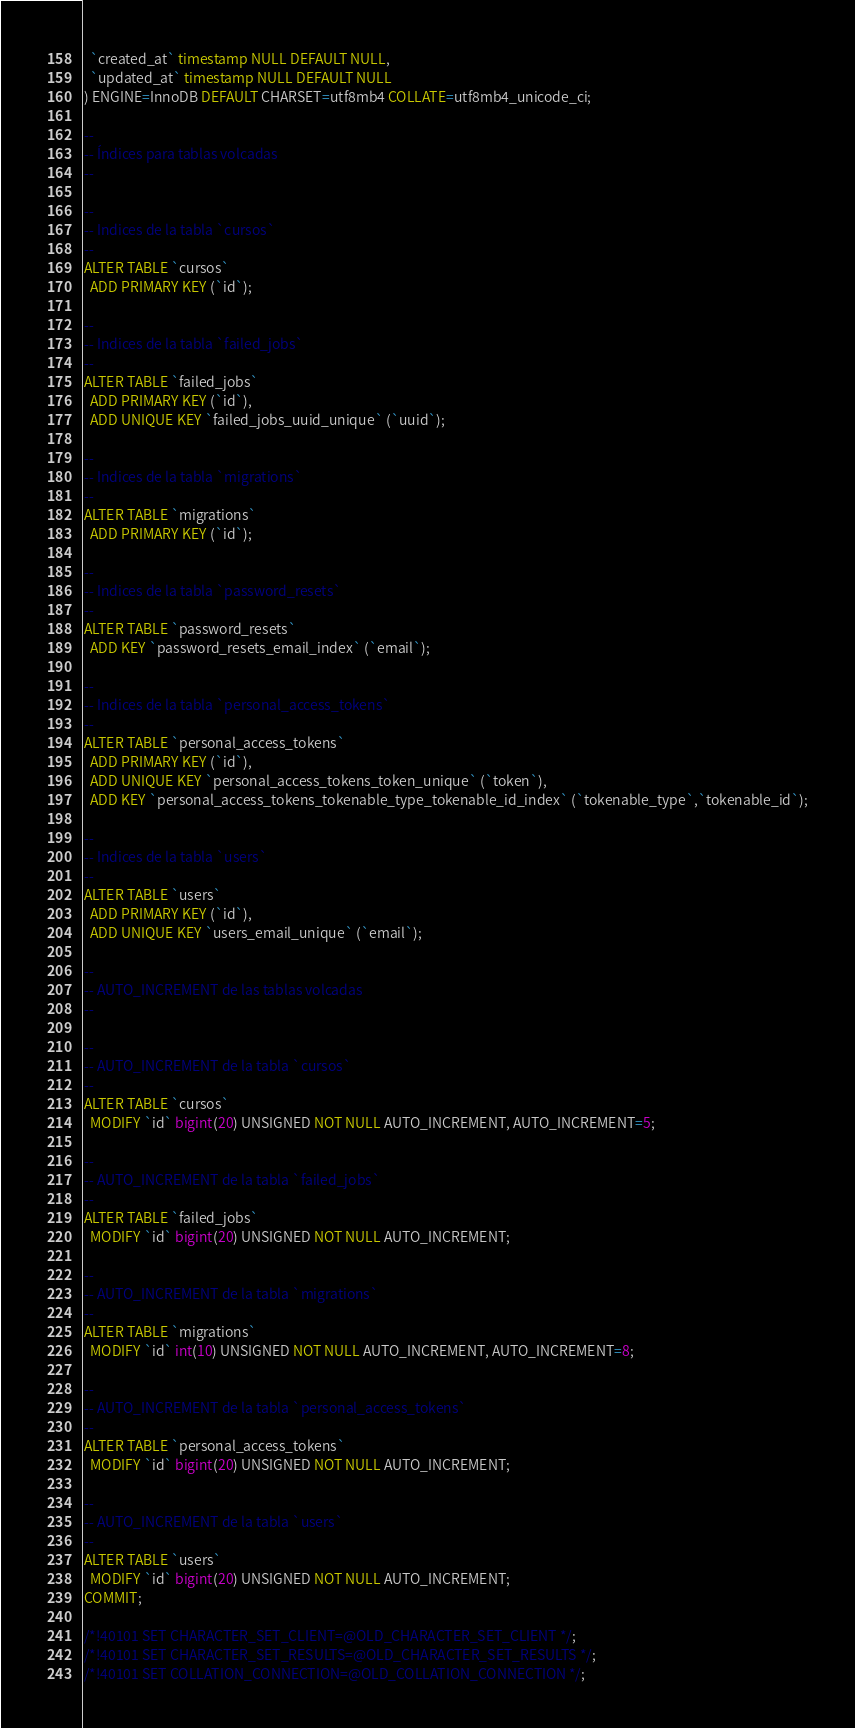Convert code to text. <code><loc_0><loc_0><loc_500><loc_500><_SQL_>  `created_at` timestamp NULL DEFAULT NULL,
  `updated_at` timestamp NULL DEFAULT NULL
) ENGINE=InnoDB DEFAULT CHARSET=utf8mb4 COLLATE=utf8mb4_unicode_ci;

--
-- Índices para tablas volcadas
--

--
-- Indices de la tabla `cursos`
--
ALTER TABLE `cursos`
  ADD PRIMARY KEY (`id`);

--
-- Indices de la tabla `failed_jobs`
--
ALTER TABLE `failed_jobs`
  ADD PRIMARY KEY (`id`),
  ADD UNIQUE KEY `failed_jobs_uuid_unique` (`uuid`);

--
-- Indices de la tabla `migrations`
--
ALTER TABLE `migrations`
  ADD PRIMARY KEY (`id`);

--
-- Indices de la tabla `password_resets`
--
ALTER TABLE `password_resets`
  ADD KEY `password_resets_email_index` (`email`);

--
-- Indices de la tabla `personal_access_tokens`
--
ALTER TABLE `personal_access_tokens`
  ADD PRIMARY KEY (`id`),
  ADD UNIQUE KEY `personal_access_tokens_token_unique` (`token`),
  ADD KEY `personal_access_tokens_tokenable_type_tokenable_id_index` (`tokenable_type`,`tokenable_id`);

--
-- Indices de la tabla `users`
--
ALTER TABLE `users`
  ADD PRIMARY KEY (`id`),
  ADD UNIQUE KEY `users_email_unique` (`email`);

--
-- AUTO_INCREMENT de las tablas volcadas
--

--
-- AUTO_INCREMENT de la tabla `cursos`
--
ALTER TABLE `cursos`
  MODIFY `id` bigint(20) UNSIGNED NOT NULL AUTO_INCREMENT, AUTO_INCREMENT=5;

--
-- AUTO_INCREMENT de la tabla `failed_jobs`
--
ALTER TABLE `failed_jobs`
  MODIFY `id` bigint(20) UNSIGNED NOT NULL AUTO_INCREMENT;

--
-- AUTO_INCREMENT de la tabla `migrations`
--
ALTER TABLE `migrations`
  MODIFY `id` int(10) UNSIGNED NOT NULL AUTO_INCREMENT, AUTO_INCREMENT=8;

--
-- AUTO_INCREMENT de la tabla `personal_access_tokens`
--
ALTER TABLE `personal_access_tokens`
  MODIFY `id` bigint(20) UNSIGNED NOT NULL AUTO_INCREMENT;

--
-- AUTO_INCREMENT de la tabla `users`
--
ALTER TABLE `users`
  MODIFY `id` bigint(20) UNSIGNED NOT NULL AUTO_INCREMENT;
COMMIT;

/*!40101 SET CHARACTER_SET_CLIENT=@OLD_CHARACTER_SET_CLIENT */;
/*!40101 SET CHARACTER_SET_RESULTS=@OLD_CHARACTER_SET_RESULTS */;
/*!40101 SET COLLATION_CONNECTION=@OLD_COLLATION_CONNECTION */;
</code> 